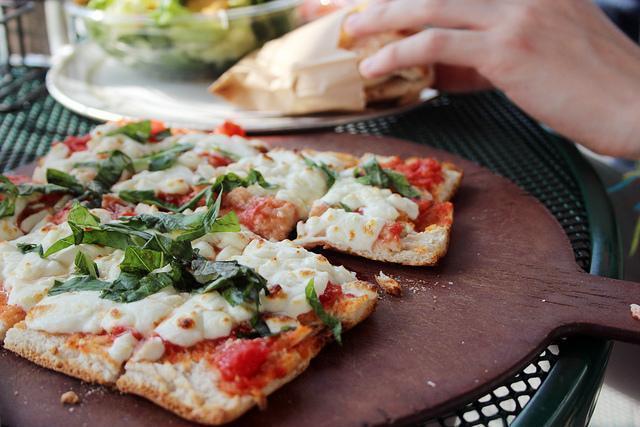Why is the pizza cut into small pieces?
Indicate the correct choice and explain in the format: 'Answer: answer
Rationale: rationale.'
Options: Looks good, easier eating, to trash, see easier. Answer: easier eating.
Rationale: The small pieces make the food easier to pick up. 